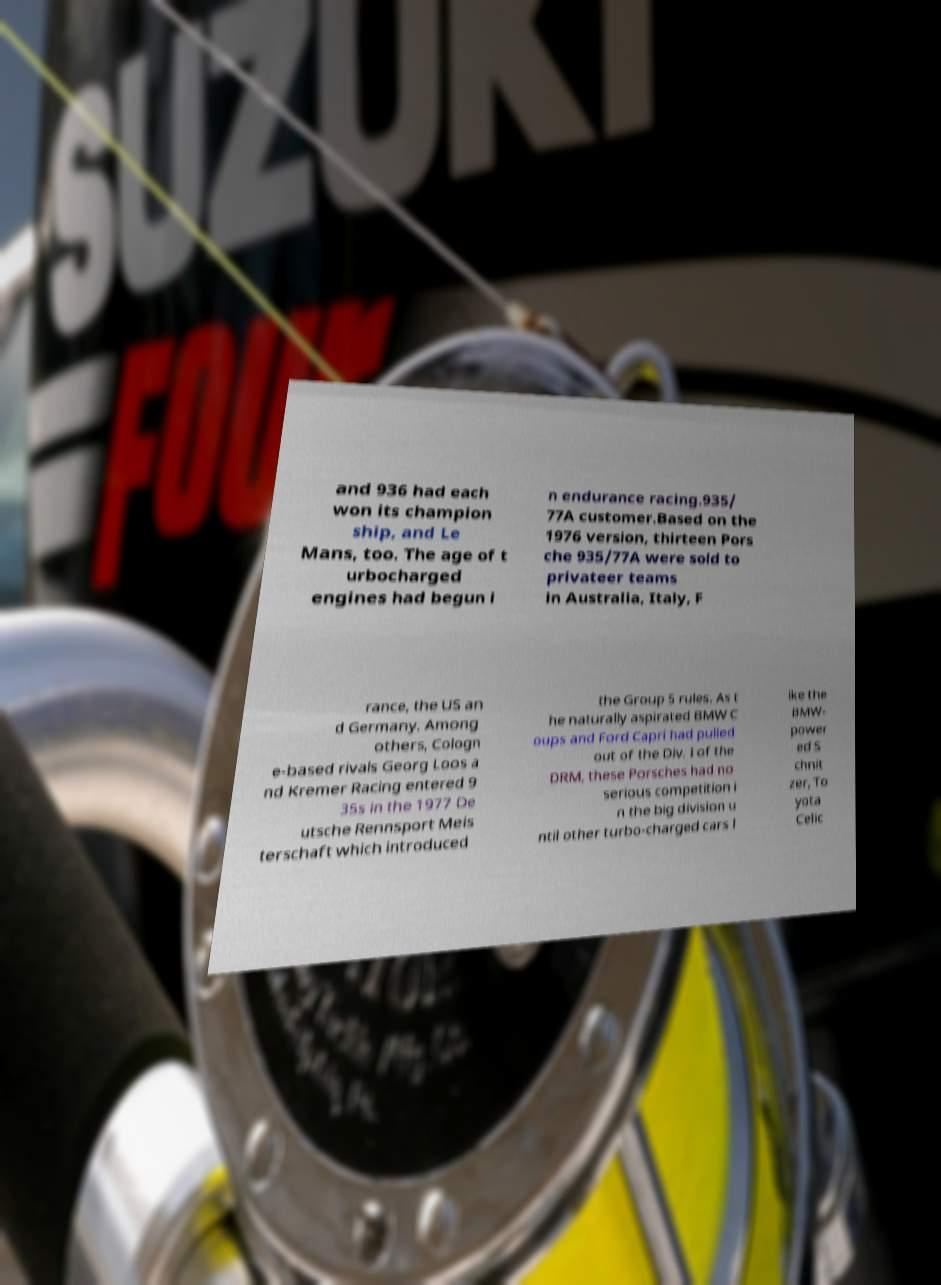Please identify and transcribe the text found in this image. and 936 had each won its champion ship, and Le Mans, too. The age of t urbocharged engines had begun i n endurance racing.935/ 77A customer.Based on the 1976 version, thirteen Pors che 935/77A were sold to privateer teams in Australia, Italy, F rance, the US an d Germany. Among others, Cologn e-based rivals Georg Loos a nd Kremer Racing entered 9 35s in the 1977 De utsche Rennsport Meis terschaft which introduced the Group 5 rules. As t he naturally aspirated BMW C oups and Ford Capri had pulled out of the Div. I of the DRM, these Porsches had no serious competition i n the big division u ntil other turbo-charged cars l ike the BMW- power ed S chnit zer, To yota Celic 